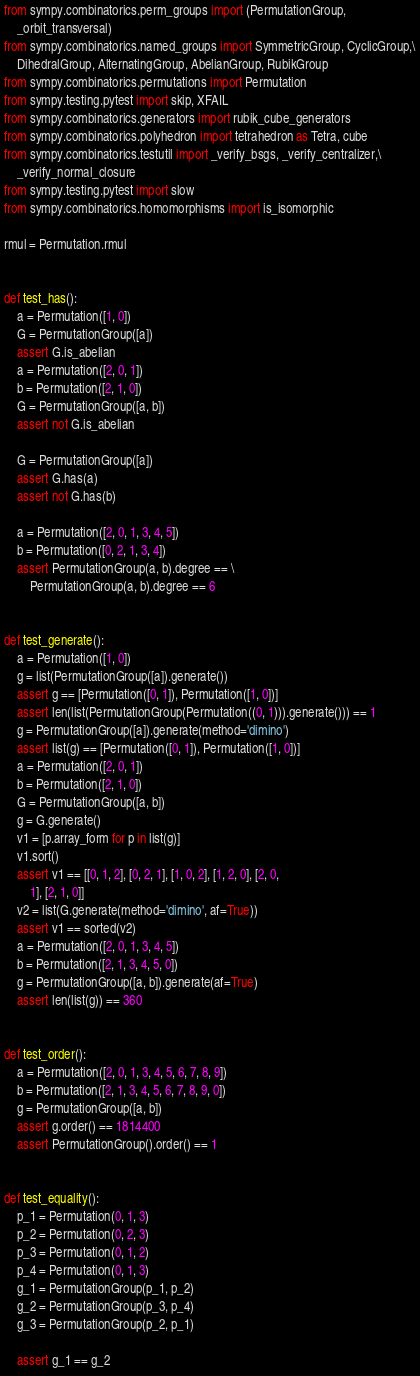<code> <loc_0><loc_0><loc_500><loc_500><_Python_>from sympy.combinatorics.perm_groups import (PermutationGroup,
    _orbit_transversal)
from sympy.combinatorics.named_groups import SymmetricGroup, CyclicGroup,\
    DihedralGroup, AlternatingGroup, AbelianGroup, RubikGroup
from sympy.combinatorics.permutations import Permutation
from sympy.testing.pytest import skip, XFAIL
from sympy.combinatorics.generators import rubik_cube_generators
from sympy.combinatorics.polyhedron import tetrahedron as Tetra, cube
from sympy.combinatorics.testutil import _verify_bsgs, _verify_centralizer,\
    _verify_normal_closure
from sympy.testing.pytest import slow
from sympy.combinatorics.homomorphisms import is_isomorphic

rmul = Permutation.rmul


def test_has():
    a = Permutation([1, 0])
    G = PermutationGroup([a])
    assert G.is_abelian
    a = Permutation([2, 0, 1])
    b = Permutation([2, 1, 0])
    G = PermutationGroup([a, b])
    assert not G.is_abelian

    G = PermutationGroup([a])
    assert G.has(a)
    assert not G.has(b)

    a = Permutation([2, 0, 1, 3, 4, 5])
    b = Permutation([0, 2, 1, 3, 4])
    assert PermutationGroup(a, b).degree == \
        PermutationGroup(a, b).degree == 6


def test_generate():
    a = Permutation([1, 0])
    g = list(PermutationGroup([a]).generate())
    assert g == [Permutation([0, 1]), Permutation([1, 0])]
    assert len(list(PermutationGroup(Permutation((0, 1))).generate())) == 1
    g = PermutationGroup([a]).generate(method='dimino')
    assert list(g) == [Permutation([0, 1]), Permutation([1, 0])]
    a = Permutation([2, 0, 1])
    b = Permutation([2, 1, 0])
    G = PermutationGroup([a, b])
    g = G.generate()
    v1 = [p.array_form for p in list(g)]
    v1.sort()
    assert v1 == [[0, 1, 2], [0, 2, 1], [1, 0, 2], [1, 2, 0], [2, 0,
        1], [2, 1, 0]]
    v2 = list(G.generate(method='dimino', af=True))
    assert v1 == sorted(v2)
    a = Permutation([2, 0, 1, 3, 4, 5])
    b = Permutation([2, 1, 3, 4, 5, 0])
    g = PermutationGroup([a, b]).generate(af=True)
    assert len(list(g)) == 360


def test_order():
    a = Permutation([2, 0, 1, 3, 4, 5, 6, 7, 8, 9])
    b = Permutation([2, 1, 3, 4, 5, 6, 7, 8, 9, 0])
    g = PermutationGroup([a, b])
    assert g.order() == 1814400
    assert PermutationGroup().order() == 1


def test_equality():
    p_1 = Permutation(0, 1, 3)
    p_2 = Permutation(0, 2, 3)
    p_3 = Permutation(0, 1, 2)
    p_4 = Permutation(0, 1, 3)
    g_1 = PermutationGroup(p_1, p_2)
    g_2 = PermutationGroup(p_3, p_4)
    g_3 = PermutationGroup(p_2, p_1)

    assert g_1 == g_2</code> 